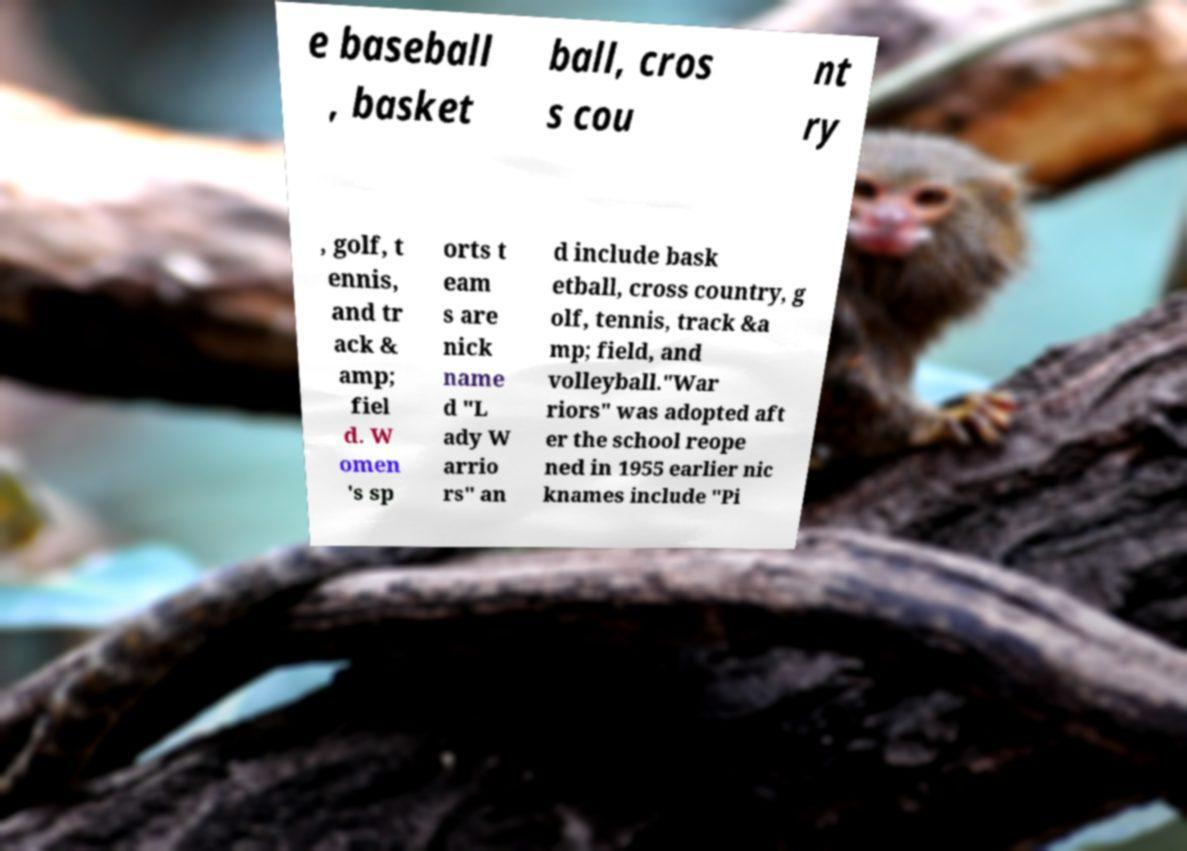For documentation purposes, I need the text within this image transcribed. Could you provide that? e baseball , basket ball, cros s cou nt ry , golf, t ennis, and tr ack & amp; fiel d. W omen 's sp orts t eam s are nick name d "L ady W arrio rs" an d include bask etball, cross country, g olf, tennis, track &a mp; field, and volleyball."War riors" was adopted aft er the school reope ned in 1955 earlier nic knames include "Pi 